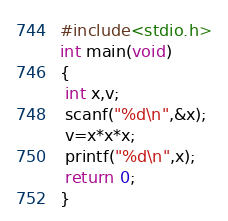Convert code to text. <code><loc_0><loc_0><loc_500><loc_500><_C_>#include<stdio.h>
int main(void)
{
 int x,v;
 scanf("%d\n",&x);
 v=x*x*x;
 printf("%d\n",x);
 return 0;
}</code> 